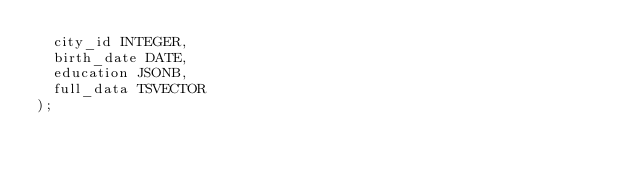Convert code to text. <code><loc_0><loc_0><loc_500><loc_500><_SQL_>  city_id INTEGER,
  birth_date DATE,
  education JSONB,
  full_data TSVECTOR
);</code> 